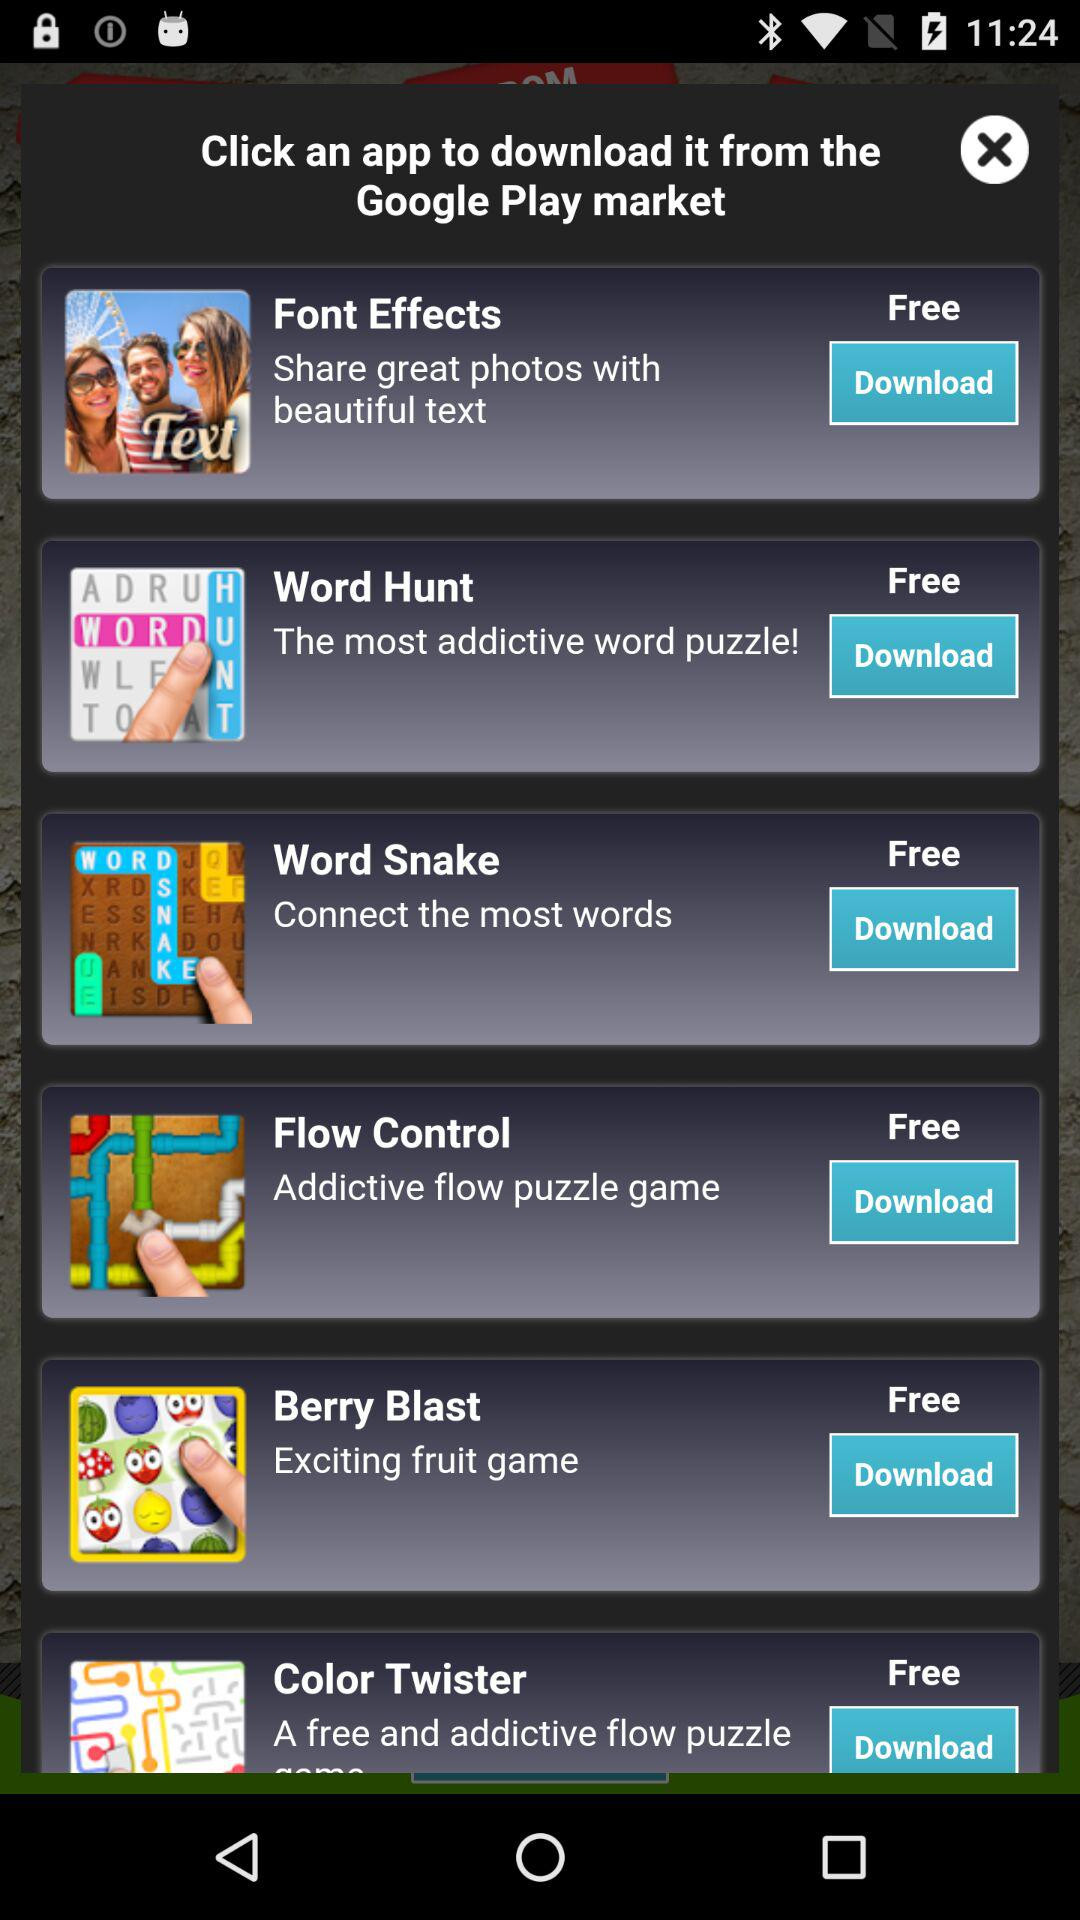What are the applications that can be downloaded from the Google Play market? The applications are "Font Effects", "Word Hunt", "Word Snake", "Flow Control", "Berry Blast" and "Color Twister". 